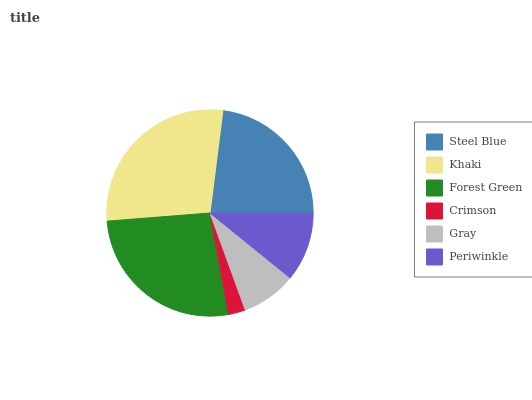Is Crimson the minimum?
Answer yes or no. Yes. Is Khaki the maximum?
Answer yes or no. Yes. Is Forest Green the minimum?
Answer yes or no. No. Is Forest Green the maximum?
Answer yes or no. No. Is Khaki greater than Forest Green?
Answer yes or no. Yes. Is Forest Green less than Khaki?
Answer yes or no. Yes. Is Forest Green greater than Khaki?
Answer yes or no. No. Is Khaki less than Forest Green?
Answer yes or no. No. Is Steel Blue the high median?
Answer yes or no. Yes. Is Periwinkle the low median?
Answer yes or no. Yes. Is Periwinkle the high median?
Answer yes or no. No. Is Khaki the low median?
Answer yes or no. No. 